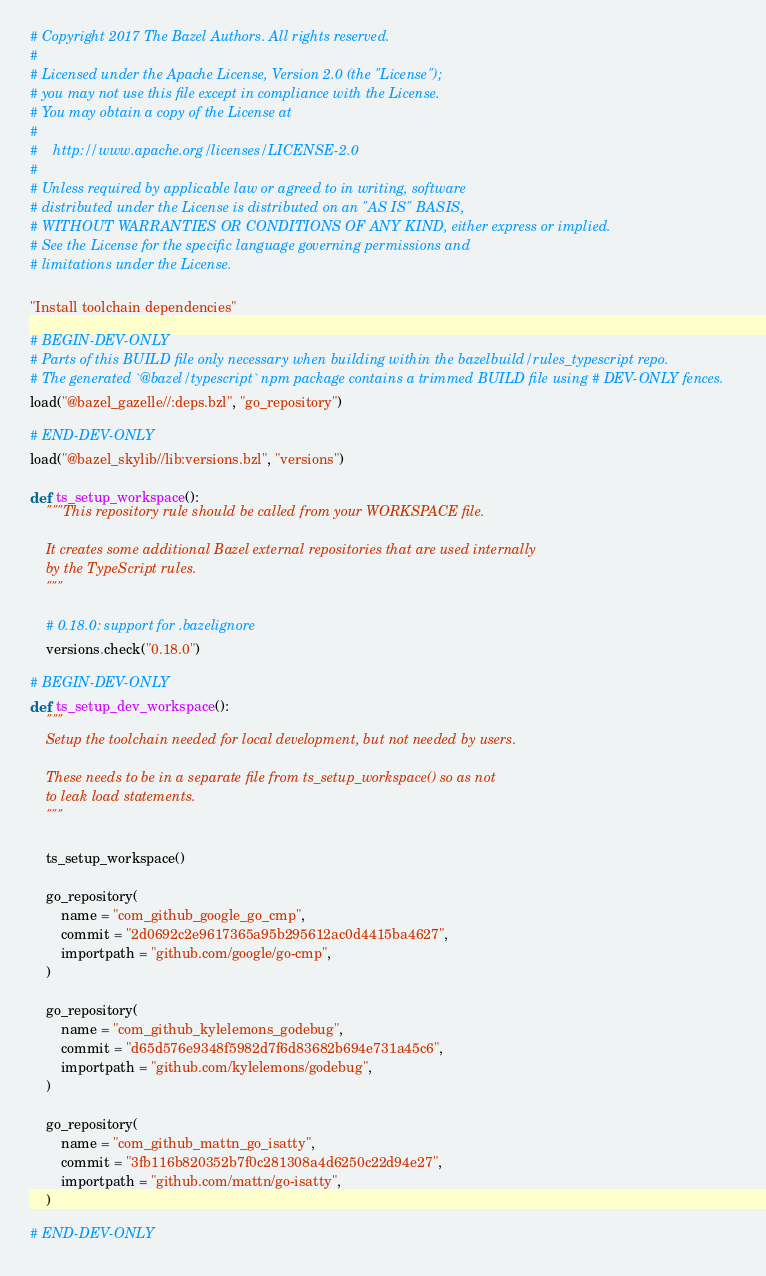<code> <loc_0><loc_0><loc_500><loc_500><_Python_># Copyright 2017 The Bazel Authors. All rights reserved.
#
# Licensed under the Apache License, Version 2.0 (the "License");
# you may not use this file except in compliance with the License.
# You may obtain a copy of the License at
#
#    http://www.apache.org/licenses/LICENSE-2.0
#
# Unless required by applicable law or agreed to in writing, software
# distributed under the License is distributed on an "AS IS" BASIS,
# WITHOUT WARRANTIES OR CONDITIONS OF ANY KIND, either express or implied.
# See the License for the specific language governing permissions and
# limitations under the License.

"Install toolchain dependencies"

# BEGIN-DEV-ONLY
# Parts of this BUILD file only necessary when building within the bazelbuild/rules_typescript repo.
# The generated `@bazel/typescript` npm package contains a trimmed BUILD file using # DEV-ONLY fences.
load("@bazel_gazelle//:deps.bzl", "go_repository")

# END-DEV-ONLY
load("@bazel_skylib//lib:versions.bzl", "versions")

def ts_setup_workspace():
    """This repository rule should be called from your WORKSPACE file.

    It creates some additional Bazel external repositories that are used internally
    by the TypeScript rules.
    """

    # 0.18.0: support for .bazelignore
    versions.check("0.18.0")

# BEGIN-DEV-ONLY
def ts_setup_dev_workspace():
    """
    Setup the toolchain needed for local development, but not needed by users.

    These needs to be in a separate file from ts_setup_workspace() so as not
    to leak load statements.
    """

    ts_setup_workspace()

    go_repository(
        name = "com_github_google_go_cmp",
        commit = "2d0692c2e9617365a95b295612ac0d4415ba4627",
        importpath = "github.com/google/go-cmp",
    )

    go_repository(
        name = "com_github_kylelemons_godebug",
        commit = "d65d576e9348f5982d7f6d83682b694e731a45c6",
        importpath = "github.com/kylelemons/godebug",
    )

    go_repository(
        name = "com_github_mattn_go_isatty",
        commit = "3fb116b820352b7f0c281308a4d6250c22d94e27",
        importpath = "github.com/mattn/go-isatty",
    )

# END-DEV-ONLY
</code> 